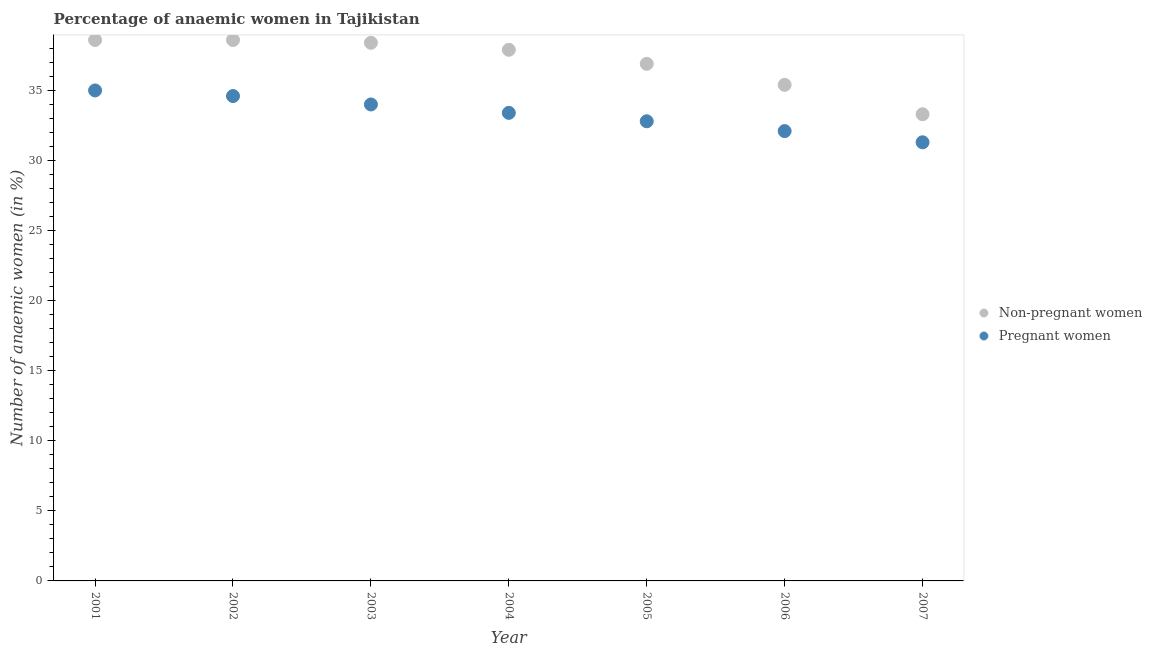Is the number of dotlines equal to the number of legend labels?
Make the answer very short. Yes. What is the percentage of non-pregnant anaemic women in 2007?
Offer a very short reply. 33.3. Across all years, what is the maximum percentage of non-pregnant anaemic women?
Offer a terse response. 38.6. Across all years, what is the minimum percentage of pregnant anaemic women?
Your answer should be compact. 31.3. In which year was the percentage of non-pregnant anaemic women minimum?
Offer a terse response. 2007. What is the total percentage of non-pregnant anaemic women in the graph?
Your answer should be very brief. 259.1. What is the difference between the percentage of non-pregnant anaemic women in 2001 and that in 2004?
Provide a short and direct response. 0.7. What is the difference between the percentage of pregnant anaemic women in 2007 and the percentage of non-pregnant anaemic women in 2004?
Your answer should be compact. -6.6. What is the average percentage of non-pregnant anaemic women per year?
Your answer should be very brief. 37.01. In the year 2005, what is the difference between the percentage of pregnant anaemic women and percentage of non-pregnant anaemic women?
Your answer should be compact. -4.1. What is the ratio of the percentage of pregnant anaemic women in 2003 to that in 2006?
Give a very brief answer. 1.06. Is the difference between the percentage of non-pregnant anaemic women in 2001 and 2003 greater than the difference between the percentage of pregnant anaemic women in 2001 and 2003?
Give a very brief answer. No. What is the difference between the highest and the second highest percentage of pregnant anaemic women?
Keep it short and to the point. 0.4. What is the difference between the highest and the lowest percentage of pregnant anaemic women?
Give a very brief answer. 3.7. In how many years, is the percentage of non-pregnant anaemic women greater than the average percentage of non-pregnant anaemic women taken over all years?
Ensure brevity in your answer.  4. What is the difference between two consecutive major ticks on the Y-axis?
Give a very brief answer. 5. Are the values on the major ticks of Y-axis written in scientific E-notation?
Ensure brevity in your answer.  No. Does the graph contain grids?
Your response must be concise. No. Where does the legend appear in the graph?
Offer a very short reply. Center right. How many legend labels are there?
Your answer should be compact. 2. How are the legend labels stacked?
Your answer should be compact. Vertical. What is the title of the graph?
Give a very brief answer. Percentage of anaemic women in Tajikistan. Does "Passenger Transport Items" appear as one of the legend labels in the graph?
Your response must be concise. No. What is the label or title of the Y-axis?
Ensure brevity in your answer.  Number of anaemic women (in %). What is the Number of anaemic women (in %) of Non-pregnant women in 2001?
Your answer should be compact. 38.6. What is the Number of anaemic women (in %) of Pregnant women in 2001?
Ensure brevity in your answer.  35. What is the Number of anaemic women (in %) of Non-pregnant women in 2002?
Ensure brevity in your answer.  38.6. What is the Number of anaemic women (in %) in Pregnant women in 2002?
Offer a very short reply. 34.6. What is the Number of anaemic women (in %) of Non-pregnant women in 2003?
Your answer should be compact. 38.4. What is the Number of anaemic women (in %) in Pregnant women in 2003?
Offer a very short reply. 34. What is the Number of anaemic women (in %) in Non-pregnant women in 2004?
Ensure brevity in your answer.  37.9. What is the Number of anaemic women (in %) in Pregnant women in 2004?
Provide a succinct answer. 33.4. What is the Number of anaemic women (in %) in Non-pregnant women in 2005?
Offer a very short reply. 36.9. What is the Number of anaemic women (in %) of Pregnant women in 2005?
Make the answer very short. 32.8. What is the Number of anaemic women (in %) of Non-pregnant women in 2006?
Your response must be concise. 35.4. What is the Number of anaemic women (in %) of Pregnant women in 2006?
Your response must be concise. 32.1. What is the Number of anaemic women (in %) of Non-pregnant women in 2007?
Provide a short and direct response. 33.3. What is the Number of anaemic women (in %) of Pregnant women in 2007?
Offer a very short reply. 31.3. Across all years, what is the maximum Number of anaemic women (in %) in Non-pregnant women?
Give a very brief answer. 38.6. Across all years, what is the minimum Number of anaemic women (in %) in Non-pregnant women?
Provide a short and direct response. 33.3. Across all years, what is the minimum Number of anaemic women (in %) of Pregnant women?
Your answer should be very brief. 31.3. What is the total Number of anaemic women (in %) of Non-pregnant women in the graph?
Offer a very short reply. 259.1. What is the total Number of anaemic women (in %) of Pregnant women in the graph?
Your response must be concise. 233.2. What is the difference between the Number of anaemic women (in %) in Pregnant women in 2001 and that in 2002?
Provide a succinct answer. 0.4. What is the difference between the Number of anaemic women (in %) of Non-pregnant women in 2001 and that in 2004?
Provide a short and direct response. 0.7. What is the difference between the Number of anaemic women (in %) of Pregnant women in 2001 and that in 2004?
Offer a very short reply. 1.6. What is the difference between the Number of anaemic women (in %) of Non-pregnant women in 2001 and that in 2006?
Provide a short and direct response. 3.2. What is the difference between the Number of anaemic women (in %) in Pregnant women in 2001 and that in 2007?
Offer a terse response. 3.7. What is the difference between the Number of anaemic women (in %) in Non-pregnant women in 2002 and that in 2003?
Offer a terse response. 0.2. What is the difference between the Number of anaemic women (in %) in Pregnant women in 2002 and that in 2003?
Your answer should be very brief. 0.6. What is the difference between the Number of anaemic women (in %) of Non-pregnant women in 2002 and that in 2005?
Offer a terse response. 1.7. What is the difference between the Number of anaemic women (in %) of Pregnant women in 2002 and that in 2005?
Make the answer very short. 1.8. What is the difference between the Number of anaemic women (in %) of Pregnant women in 2002 and that in 2006?
Ensure brevity in your answer.  2.5. What is the difference between the Number of anaemic women (in %) in Non-pregnant women in 2002 and that in 2007?
Keep it short and to the point. 5.3. What is the difference between the Number of anaemic women (in %) of Non-pregnant women in 2003 and that in 2005?
Give a very brief answer. 1.5. What is the difference between the Number of anaemic women (in %) of Non-pregnant women in 2003 and that in 2006?
Provide a short and direct response. 3. What is the difference between the Number of anaemic women (in %) of Pregnant women in 2004 and that in 2006?
Give a very brief answer. 1.3. What is the difference between the Number of anaemic women (in %) of Non-pregnant women in 2005 and that in 2006?
Ensure brevity in your answer.  1.5. What is the difference between the Number of anaemic women (in %) of Pregnant women in 2005 and that in 2006?
Provide a succinct answer. 0.7. What is the difference between the Number of anaemic women (in %) in Pregnant women in 2005 and that in 2007?
Keep it short and to the point. 1.5. What is the difference between the Number of anaemic women (in %) in Non-pregnant women in 2006 and that in 2007?
Provide a succinct answer. 2.1. What is the difference between the Number of anaemic women (in %) in Pregnant women in 2006 and that in 2007?
Your answer should be compact. 0.8. What is the difference between the Number of anaemic women (in %) in Non-pregnant women in 2001 and the Number of anaemic women (in %) in Pregnant women in 2005?
Provide a succinct answer. 5.8. What is the difference between the Number of anaemic women (in %) in Non-pregnant women in 2001 and the Number of anaemic women (in %) in Pregnant women in 2006?
Offer a very short reply. 6.5. What is the difference between the Number of anaemic women (in %) of Non-pregnant women in 2002 and the Number of anaemic women (in %) of Pregnant women in 2003?
Keep it short and to the point. 4.6. What is the difference between the Number of anaemic women (in %) in Non-pregnant women in 2002 and the Number of anaemic women (in %) in Pregnant women in 2005?
Give a very brief answer. 5.8. What is the difference between the Number of anaemic women (in %) in Non-pregnant women in 2002 and the Number of anaemic women (in %) in Pregnant women in 2006?
Give a very brief answer. 6.5. What is the difference between the Number of anaemic women (in %) in Non-pregnant women in 2004 and the Number of anaemic women (in %) in Pregnant women in 2006?
Keep it short and to the point. 5.8. What is the difference between the Number of anaemic women (in %) in Non-pregnant women in 2005 and the Number of anaemic women (in %) in Pregnant women in 2006?
Provide a short and direct response. 4.8. What is the difference between the Number of anaemic women (in %) in Non-pregnant women in 2005 and the Number of anaemic women (in %) in Pregnant women in 2007?
Your answer should be very brief. 5.6. What is the average Number of anaemic women (in %) of Non-pregnant women per year?
Offer a terse response. 37.01. What is the average Number of anaemic women (in %) in Pregnant women per year?
Provide a succinct answer. 33.31. In the year 2001, what is the difference between the Number of anaemic women (in %) of Non-pregnant women and Number of anaemic women (in %) of Pregnant women?
Your response must be concise. 3.6. In the year 2002, what is the difference between the Number of anaemic women (in %) in Non-pregnant women and Number of anaemic women (in %) in Pregnant women?
Your response must be concise. 4. In the year 2004, what is the difference between the Number of anaemic women (in %) in Non-pregnant women and Number of anaemic women (in %) in Pregnant women?
Ensure brevity in your answer.  4.5. In the year 2005, what is the difference between the Number of anaemic women (in %) in Non-pregnant women and Number of anaemic women (in %) in Pregnant women?
Keep it short and to the point. 4.1. In the year 2006, what is the difference between the Number of anaemic women (in %) in Non-pregnant women and Number of anaemic women (in %) in Pregnant women?
Provide a short and direct response. 3.3. In the year 2007, what is the difference between the Number of anaemic women (in %) of Non-pregnant women and Number of anaemic women (in %) of Pregnant women?
Give a very brief answer. 2. What is the ratio of the Number of anaemic women (in %) in Pregnant women in 2001 to that in 2002?
Give a very brief answer. 1.01. What is the ratio of the Number of anaemic women (in %) in Pregnant women in 2001 to that in 2003?
Your answer should be compact. 1.03. What is the ratio of the Number of anaemic women (in %) of Non-pregnant women in 2001 to that in 2004?
Provide a short and direct response. 1.02. What is the ratio of the Number of anaemic women (in %) of Pregnant women in 2001 to that in 2004?
Your response must be concise. 1.05. What is the ratio of the Number of anaemic women (in %) in Non-pregnant women in 2001 to that in 2005?
Ensure brevity in your answer.  1.05. What is the ratio of the Number of anaemic women (in %) in Pregnant women in 2001 to that in 2005?
Ensure brevity in your answer.  1.07. What is the ratio of the Number of anaemic women (in %) in Non-pregnant women in 2001 to that in 2006?
Keep it short and to the point. 1.09. What is the ratio of the Number of anaemic women (in %) in Pregnant women in 2001 to that in 2006?
Your answer should be compact. 1.09. What is the ratio of the Number of anaemic women (in %) of Non-pregnant women in 2001 to that in 2007?
Provide a short and direct response. 1.16. What is the ratio of the Number of anaemic women (in %) in Pregnant women in 2001 to that in 2007?
Offer a very short reply. 1.12. What is the ratio of the Number of anaemic women (in %) in Pregnant women in 2002 to that in 2003?
Make the answer very short. 1.02. What is the ratio of the Number of anaemic women (in %) of Non-pregnant women in 2002 to that in 2004?
Your answer should be very brief. 1.02. What is the ratio of the Number of anaemic women (in %) in Pregnant women in 2002 to that in 2004?
Make the answer very short. 1.04. What is the ratio of the Number of anaemic women (in %) of Non-pregnant women in 2002 to that in 2005?
Give a very brief answer. 1.05. What is the ratio of the Number of anaemic women (in %) in Pregnant women in 2002 to that in 2005?
Offer a terse response. 1.05. What is the ratio of the Number of anaemic women (in %) in Non-pregnant women in 2002 to that in 2006?
Provide a succinct answer. 1.09. What is the ratio of the Number of anaemic women (in %) in Pregnant women in 2002 to that in 2006?
Provide a short and direct response. 1.08. What is the ratio of the Number of anaemic women (in %) in Non-pregnant women in 2002 to that in 2007?
Offer a terse response. 1.16. What is the ratio of the Number of anaemic women (in %) of Pregnant women in 2002 to that in 2007?
Offer a terse response. 1.11. What is the ratio of the Number of anaemic women (in %) in Non-pregnant women in 2003 to that in 2004?
Offer a very short reply. 1.01. What is the ratio of the Number of anaemic women (in %) of Pregnant women in 2003 to that in 2004?
Provide a short and direct response. 1.02. What is the ratio of the Number of anaemic women (in %) in Non-pregnant women in 2003 to that in 2005?
Your answer should be compact. 1.04. What is the ratio of the Number of anaemic women (in %) in Pregnant women in 2003 to that in 2005?
Provide a short and direct response. 1.04. What is the ratio of the Number of anaemic women (in %) of Non-pregnant women in 2003 to that in 2006?
Ensure brevity in your answer.  1.08. What is the ratio of the Number of anaemic women (in %) of Pregnant women in 2003 to that in 2006?
Make the answer very short. 1.06. What is the ratio of the Number of anaemic women (in %) in Non-pregnant women in 2003 to that in 2007?
Your answer should be very brief. 1.15. What is the ratio of the Number of anaemic women (in %) in Pregnant women in 2003 to that in 2007?
Give a very brief answer. 1.09. What is the ratio of the Number of anaemic women (in %) of Non-pregnant women in 2004 to that in 2005?
Make the answer very short. 1.03. What is the ratio of the Number of anaemic women (in %) of Pregnant women in 2004 to that in 2005?
Make the answer very short. 1.02. What is the ratio of the Number of anaemic women (in %) in Non-pregnant women in 2004 to that in 2006?
Your response must be concise. 1.07. What is the ratio of the Number of anaemic women (in %) in Pregnant women in 2004 to that in 2006?
Offer a very short reply. 1.04. What is the ratio of the Number of anaemic women (in %) of Non-pregnant women in 2004 to that in 2007?
Keep it short and to the point. 1.14. What is the ratio of the Number of anaemic women (in %) in Pregnant women in 2004 to that in 2007?
Your answer should be very brief. 1.07. What is the ratio of the Number of anaemic women (in %) in Non-pregnant women in 2005 to that in 2006?
Ensure brevity in your answer.  1.04. What is the ratio of the Number of anaemic women (in %) of Pregnant women in 2005 to that in 2006?
Give a very brief answer. 1.02. What is the ratio of the Number of anaemic women (in %) in Non-pregnant women in 2005 to that in 2007?
Provide a succinct answer. 1.11. What is the ratio of the Number of anaemic women (in %) in Pregnant women in 2005 to that in 2007?
Provide a short and direct response. 1.05. What is the ratio of the Number of anaemic women (in %) of Non-pregnant women in 2006 to that in 2007?
Offer a very short reply. 1.06. What is the ratio of the Number of anaemic women (in %) of Pregnant women in 2006 to that in 2007?
Make the answer very short. 1.03. What is the difference between the highest and the second highest Number of anaemic women (in %) of Pregnant women?
Offer a terse response. 0.4. What is the difference between the highest and the lowest Number of anaemic women (in %) of Non-pregnant women?
Offer a terse response. 5.3. 